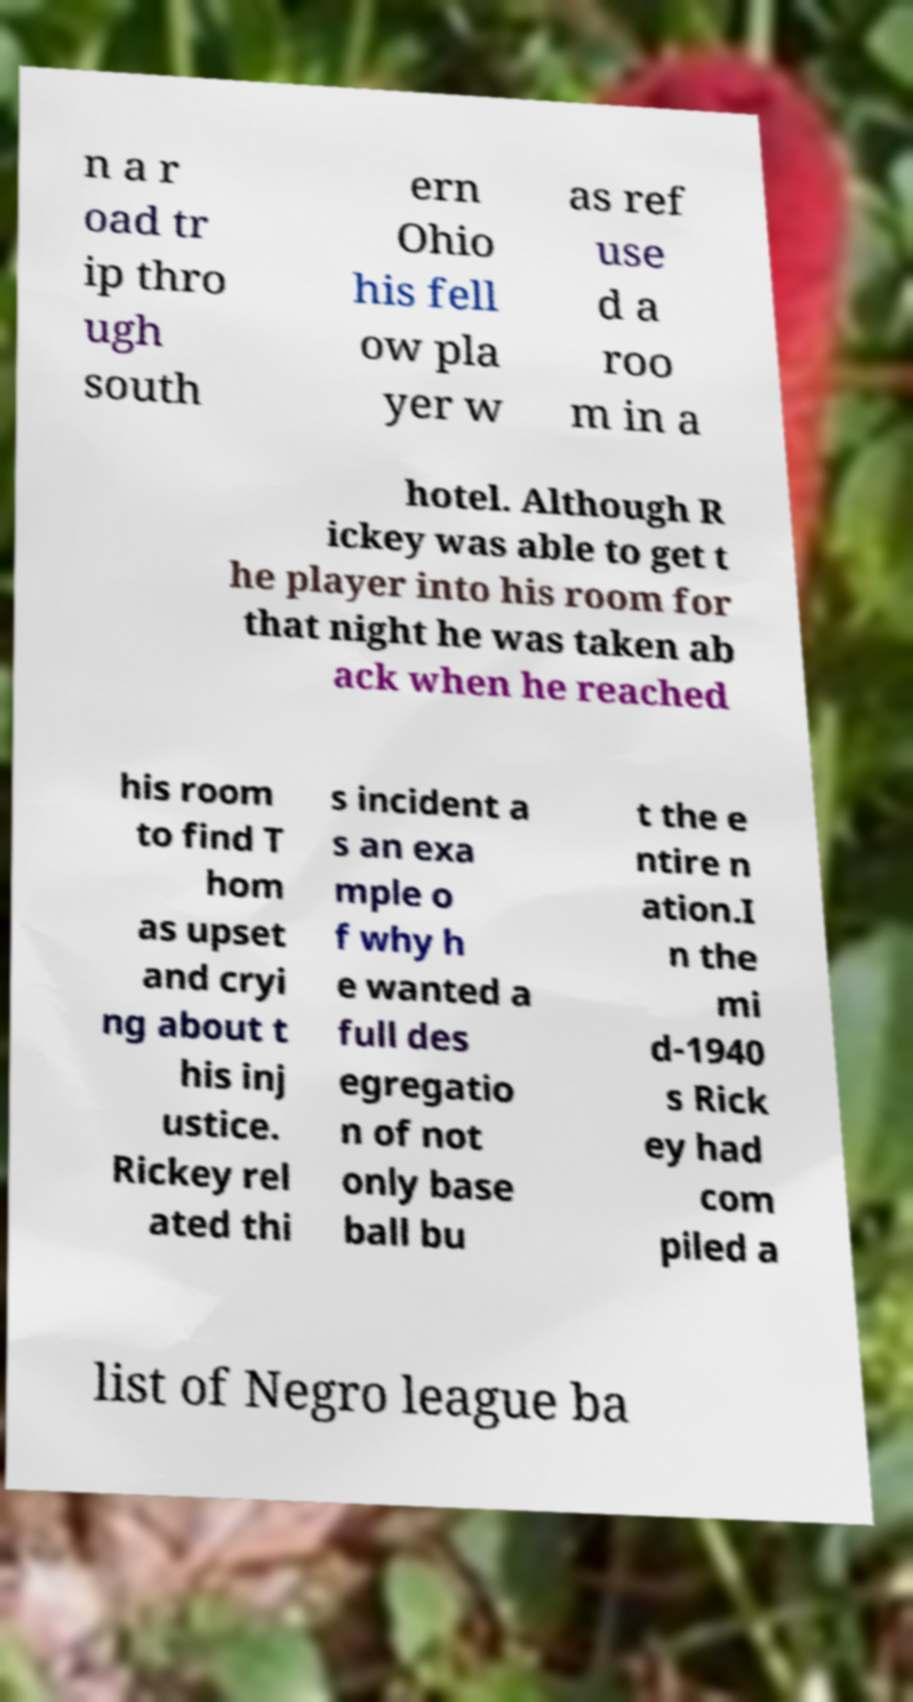Can you read and provide the text displayed in the image?This photo seems to have some interesting text. Can you extract and type it out for me? n a r oad tr ip thro ugh south ern Ohio his fell ow pla yer w as ref use d a roo m in a hotel. Although R ickey was able to get t he player into his room for that night he was taken ab ack when he reached his room to find T hom as upset and cryi ng about t his inj ustice. Rickey rel ated thi s incident a s an exa mple o f why h e wanted a full des egregatio n of not only base ball bu t the e ntire n ation.I n the mi d-1940 s Rick ey had com piled a list of Negro league ba 